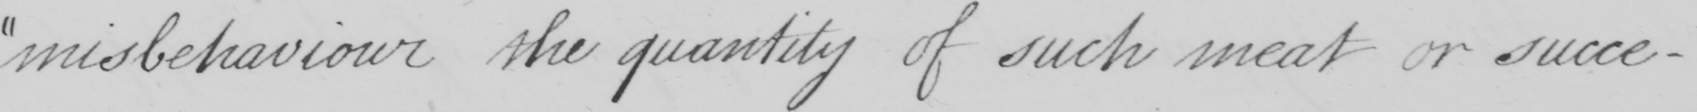What is written in this line of handwriting? misbehaviour the quantity of such meat or succe- 